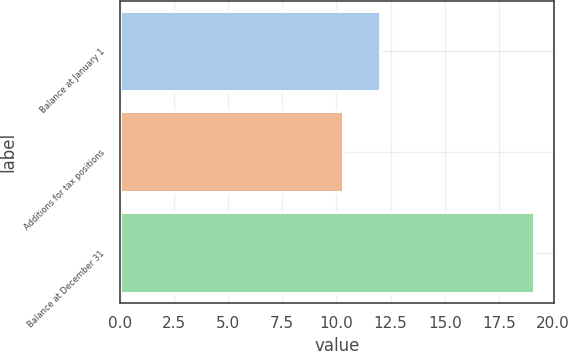Convert chart. <chart><loc_0><loc_0><loc_500><loc_500><bar_chart><fcel>Balance at January 1<fcel>Additions for tax positions<fcel>Balance at December 31<nl><fcel>12<fcel>10.3<fcel>19.1<nl></chart> 